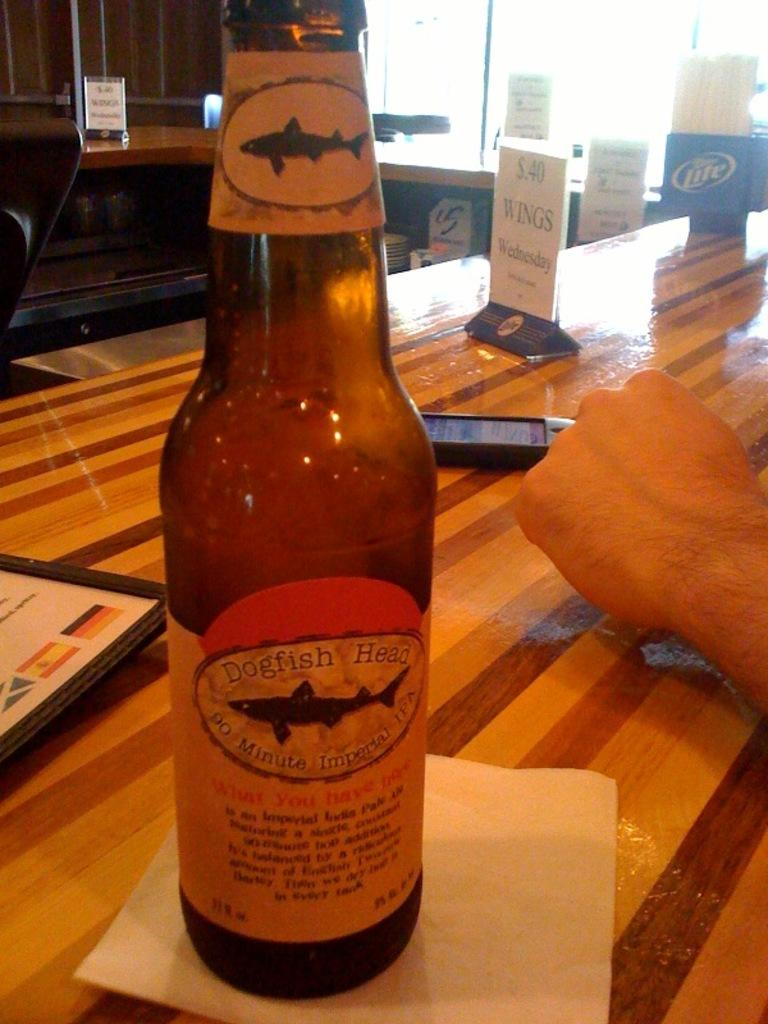<image>
Share a concise interpretation of the image provided. A bottle with a label saying "Dogfish" is on a napkin next to a person's hand. 